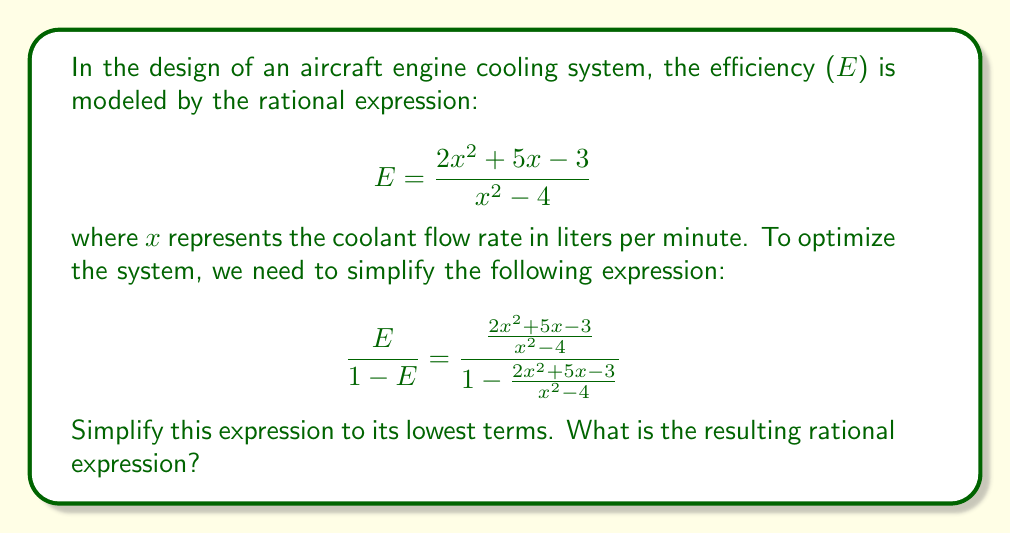Provide a solution to this math problem. Let's approach this step-by-step:

1) First, let's focus on the denominator of the main fraction. We can simplify $1 - \frac{2x^2 + 5x - 3}{x^2 - 4}$:

   $$1 - \frac{2x^2 + 5x - 3}{x^2 - 4} = \frac{x^2 - 4}{x^2 - 4} - \frac{2x^2 + 5x - 3}{x^2 - 4} = \frac{(x^2 - 4) - (2x^2 + 5x - 3)}{x^2 - 4}$$

2) Simplify the numerator:

   $$\frac{(x^2 - 4) - (2x^2 + 5x - 3)}{x^2 - 4} = \frac{x^2 - 4 - 2x^2 - 5x + 3}{x^2 - 4} = \frac{-x^2 - 5x - 1}{x^2 - 4}$$

3) Now our main expression looks like this:

   $$\frac{\frac{2x^2 + 5x - 3}{x^2 - 4}}{\frac{-x^2 - 5x - 1}{x^2 - 4}}$$

4) When dividing fractions, we multiply by the reciprocal. Also, $(x^2 - 4)$ cancels out:

   $$\frac{2x^2 + 5x - 3}{-x^2 - 5x - 1}$$

5) To get the lowest terms, we need to factor both numerator and denominator:

   Numerator: $2x^2 + 5x - 3 = (2x-1)(x+3)$
   Denominator: $-x^2 - 5x - 1 = -(x+1)(x+4)$

6) Our expression is now:

   $$\frac{(2x-1)(x+3)}{-(x+1)(x+4)}$$

7) Simplify by moving the negative sign to the numerator:

   $$-\frac{(2x-1)(x+3)}{(x+1)(x+4)}$$

This is the simplest form of the rational expression.
Answer: $-\frac{(2x-1)(x+3)}{(x+1)(x+4)}$ 